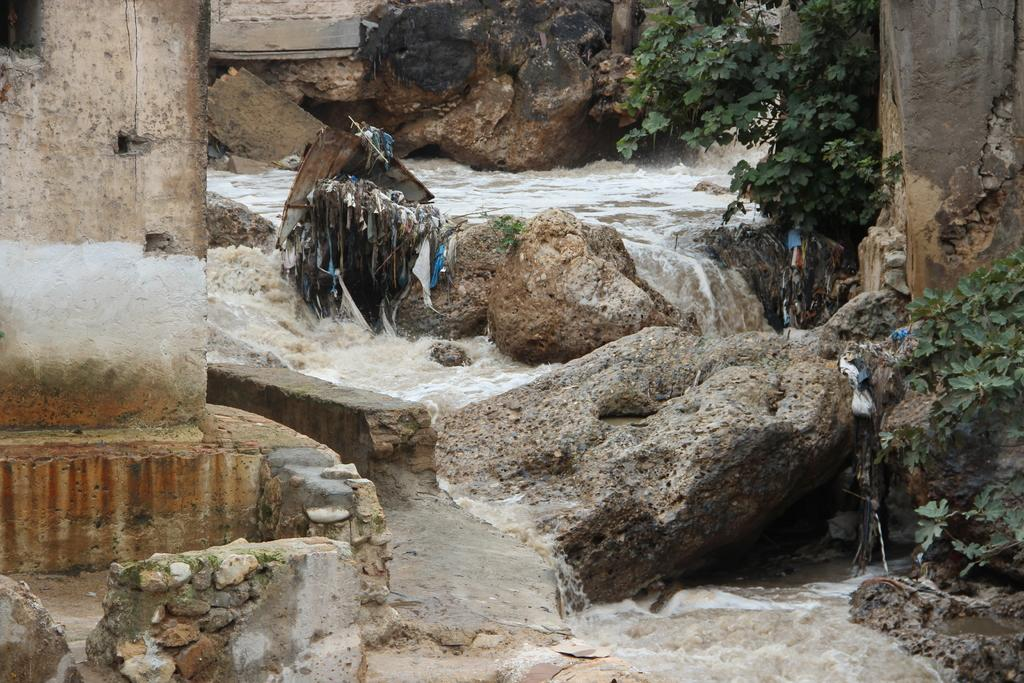What type of natural elements can be seen in the image? There are rocks and plants in the image. Can you describe the water in the image? Water is visible in the background of the image. What advice is the frog giving to the cows in the image? There is no frog or cows present in the image, so no advice can be given. 